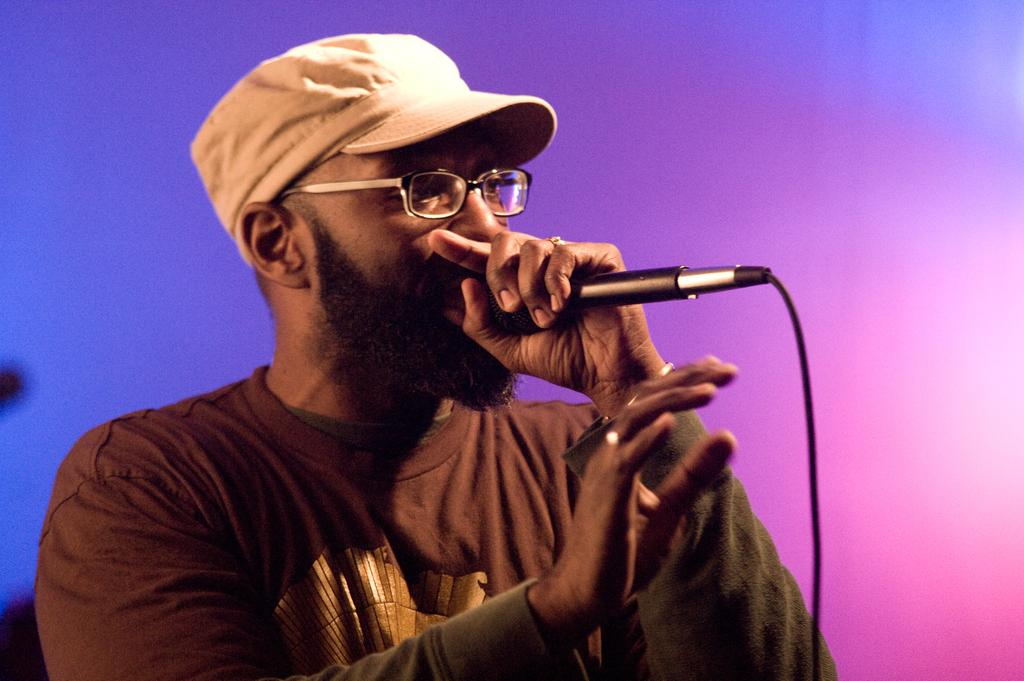What is the main subject of the image? The main subject of the image is a man. What is the man doing in the image? The man is standing and talking into a microphone. What is the man wearing on his head? The man is wearing a cap. What is the man holding in his hands? The man is holding a microphone. What can be seen on the man's face? The man is wearing glasses. How many angles are present in the image? There are no angles mentioned or visible in the image. --- Facts: 1. There is a car in the image. 2. The car is red. 3. The car has four wheels. 4. The car has a sunroof. 5. The car has a spoiler. 6. The car is parked on the street. Absurd Topics: rainbow Conversation: What is the main subject of the image? The main subject of the image is a car. What color is the car? The car is red. How many wheels does the car have? The car has four wheels. What additional feature does the car have? The car has a sunroof. What other feature can be seen on the car? The car has a spoiler. Where is the car located in the image? The car is parked on the street. Reasoning: Let's think step by step in order to produce the conversation. We start by identifying the main subject of the image, which is the car. Next, we describe specific features of the car, such as its color, the number of wheels it has, and any additional features it may have. Then, we observe the car's location in the image, which is parked on the street. Absurd Question/Answer: What type of rainbow can be seen in the image? There is no rainbow present in the image. --- Facts: 1. There is a group of people in the image. 2. The people are wearing hats. 3. The people are holding hands. 4. The people are standing in a circle. 5. The people are smiling. Absurd Topics: elephant, piano Conversation: What is the main subject of the image? The main subject of the image is a group of people. What are the people wearing on their heads? The people are wearing hats. What are the people doing with their hands? The people are holding hands. How are the people positioned in the image? The people are standing in a circle. What expression can be seen on the people's faces? The people are smiling. Reasoning: Let's think step by step in order to produce the conversation. We start by identifying the main subject of the image, which is the group of people. Next, we describe specific features of the people, such as what they 